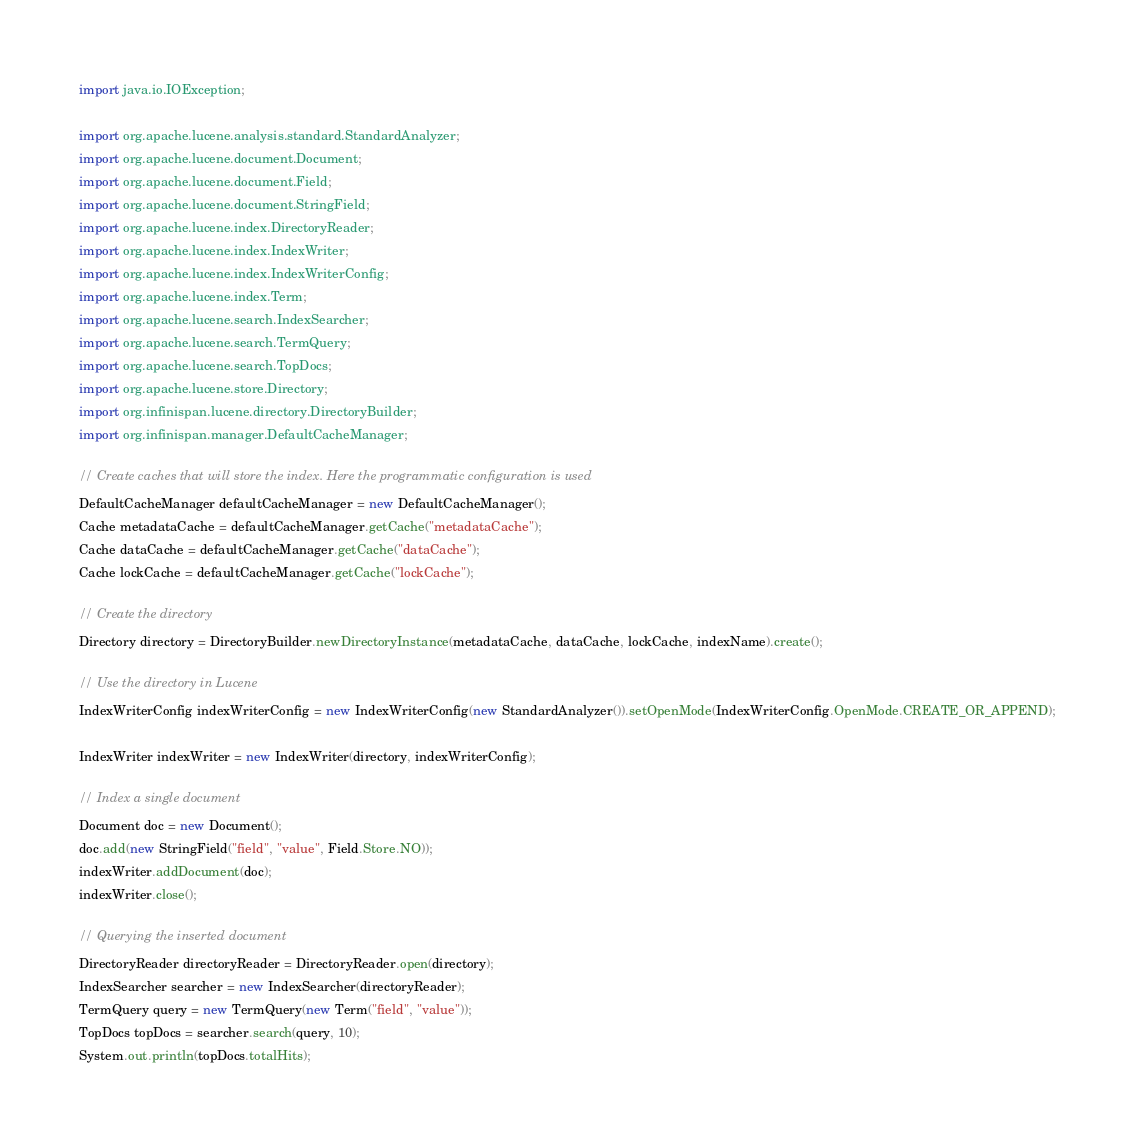<code> <loc_0><loc_0><loc_500><loc_500><_Java_>import java.io.IOException;

import org.apache.lucene.analysis.standard.StandardAnalyzer;
import org.apache.lucene.document.Document;
import org.apache.lucene.document.Field;
import org.apache.lucene.document.StringField;
import org.apache.lucene.index.DirectoryReader;
import org.apache.lucene.index.IndexWriter;
import org.apache.lucene.index.IndexWriterConfig;
import org.apache.lucene.index.Term;
import org.apache.lucene.search.IndexSearcher;
import org.apache.lucene.search.TermQuery;
import org.apache.lucene.search.TopDocs;
import org.apache.lucene.store.Directory;
import org.infinispan.lucene.directory.DirectoryBuilder;
import org.infinispan.manager.DefaultCacheManager;

// Create caches that will store the index. Here the programmatic configuration is used
DefaultCacheManager defaultCacheManager = new DefaultCacheManager();
Cache metadataCache = defaultCacheManager.getCache("metadataCache");
Cache dataCache = defaultCacheManager.getCache("dataCache");
Cache lockCache = defaultCacheManager.getCache("lockCache");

// Create the directory
Directory directory = DirectoryBuilder.newDirectoryInstance(metadataCache, dataCache, lockCache, indexName).create();

// Use the directory in Lucene
IndexWriterConfig indexWriterConfig = new IndexWriterConfig(new StandardAnalyzer()).setOpenMode(IndexWriterConfig.OpenMode.CREATE_OR_APPEND);

IndexWriter indexWriter = new IndexWriter(directory, indexWriterConfig);

// Index a single document
Document doc = new Document();
doc.add(new StringField("field", "value", Field.Store.NO));
indexWriter.addDocument(doc);
indexWriter.close();

// Querying the inserted document
DirectoryReader directoryReader = DirectoryReader.open(directory);
IndexSearcher searcher = new IndexSearcher(directoryReader);
TermQuery query = new TermQuery(new Term("field", "value"));
TopDocs topDocs = searcher.search(query, 10);
System.out.println(topDocs.totalHits);
</code> 